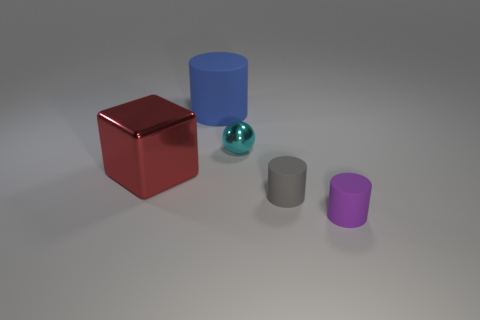There is a metallic thing on the right side of the cylinder that is behind the red metallic cube; what is its color?
Your answer should be compact. Cyan. How many other objects are the same shape as the large red object?
Provide a succinct answer. 0. Are there any blue objects made of the same material as the blue cylinder?
Make the answer very short. No. There is another cylinder that is the same size as the purple cylinder; what is its material?
Ensure brevity in your answer.  Rubber. What is the color of the shiny object that is on the right side of the cylinder behind the big object in front of the blue cylinder?
Provide a succinct answer. Cyan. There is a tiny rubber object that is on the right side of the small gray thing; does it have the same shape as the tiny thing that is on the left side of the tiny gray rubber cylinder?
Offer a terse response. No. How many big cyan things are there?
Your response must be concise. 0. There is a cylinder that is the same size as the cube; what color is it?
Your answer should be compact. Blue. Do the cylinder to the right of the tiny gray rubber cylinder and the large blue cylinder that is left of the cyan thing have the same material?
Your answer should be compact. Yes. What is the size of the matte thing behind the large red thing that is on the left side of the tiny gray matte thing?
Give a very brief answer. Large. 